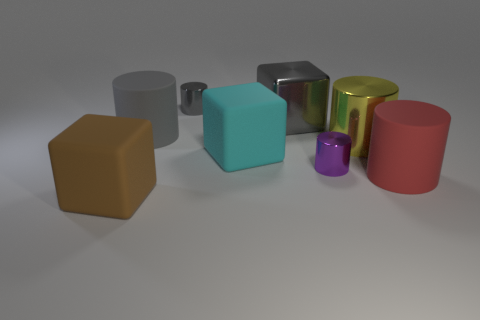Subtract all large yellow cylinders. How many cylinders are left? 4 Subtract all yellow blocks. How many gray cylinders are left? 2 Add 2 gray matte cylinders. How many objects exist? 10 Subtract all yellow cylinders. How many cylinders are left? 4 Subtract 2 cylinders. How many cylinders are left? 3 Subtract all blocks. How many objects are left? 5 Subtract all brown things. Subtract all red rubber cubes. How many objects are left? 7 Add 6 cyan matte objects. How many cyan matte objects are left? 7 Add 8 yellow cylinders. How many yellow cylinders exist? 9 Subtract 0 blue balls. How many objects are left? 8 